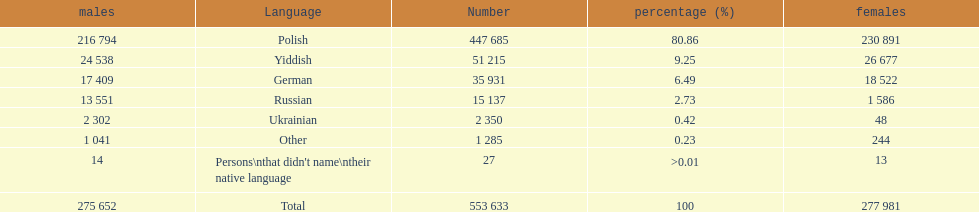Which is the least spoken language? Ukrainian. 